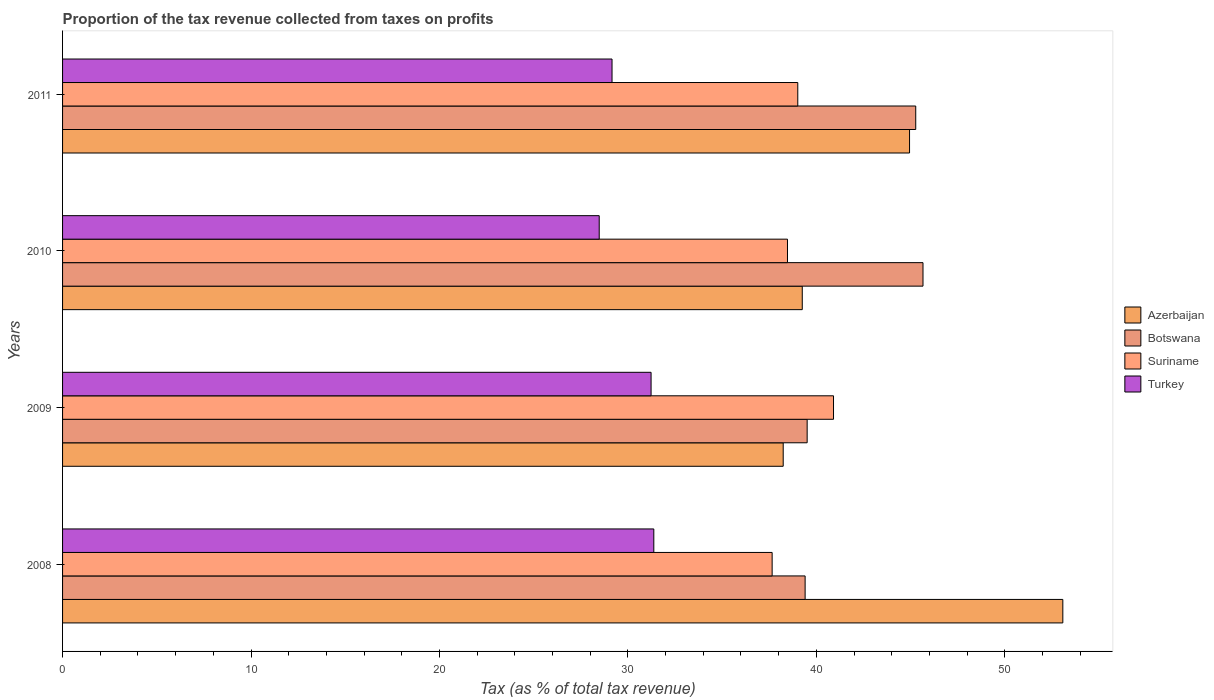How many groups of bars are there?
Keep it short and to the point. 4. Are the number of bars on each tick of the Y-axis equal?
Make the answer very short. Yes. What is the label of the 3rd group of bars from the top?
Give a very brief answer. 2009. In how many cases, is the number of bars for a given year not equal to the number of legend labels?
Provide a short and direct response. 0. What is the proportion of the tax revenue collected in Azerbaijan in 2009?
Ensure brevity in your answer.  38.24. Across all years, what is the maximum proportion of the tax revenue collected in Suriname?
Your response must be concise. 40.91. Across all years, what is the minimum proportion of the tax revenue collected in Azerbaijan?
Your answer should be compact. 38.24. In which year was the proportion of the tax revenue collected in Turkey minimum?
Your response must be concise. 2010. What is the total proportion of the tax revenue collected in Botswana in the graph?
Ensure brevity in your answer.  169.85. What is the difference between the proportion of the tax revenue collected in Botswana in 2008 and that in 2011?
Your response must be concise. -5.87. What is the difference between the proportion of the tax revenue collected in Turkey in 2010 and the proportion of the tax revenue collected in Azerbaijan in 2009?
Make the answer very short. -9.76. What is the average proportion of the tax revenue collected in Azerbaijan per year?
Your answer should be compact. 43.88. In the year 2009, what is the difference between the proportion of the tax revenue collected in Turkey and proportion of the tax revenue collected in Azerbaijan?
Your answer should be compact. -7.01. What is the ratio of the proportion of the tax revenue collected in Turkey in 2008 to that in 2009?
Give a very brief answer. 1. Is the difference between the proportion of the tax revenue collected in Turkey in 2009 and 2011 greater than the difference between the proportion of the tax revenue collected in Azerbaijan in 2009 and 2011?
Your answer should be very brief. Yes. What is the difference between the highest and the second highest proportion of the tax revenue collected in Azerbaijan?
Offer a very short reply. 8.13. What is the difference between the highest and the lowest proportion of the tax revenue collected in Suriname?
Give a very brief answer. 3.26. Is the sum of the proportion of the tax revenue collected in Turkey in 2010 and 2011 greater than the maximum proportion of the tax revenue collected in Botswana across all years?
Give a very brief answer. Yes. What does the 1st bar from the top in 2009 represents?
Your answer should be very brief. Turkey. What does the 3rd bar from the bottom in 2011 represents?
Provide a succinct answer. Suriname. How many bars are there?
Your answer should be very brief. 16. Are the values on the major ticks of X-axis written in scientific E-notation?
Your answer should be very brief. No. Does the graph contain grids?
Offer a very short reply. No. What is the title of the graph?
Provide a succinct answer. Proportion of the tax revenue collected from taxes on profits. Does "Curacao" appear as one of the legend labels in the graph?
Your answer should be compact. No. What is the label or title of the X-axis?
Your answer should be very brief. Tax (as % of total tax revenue). What is the label or title of the Y-axis?
Offer a very short reply. Years. What is the Tax (as % of total tax revenue) of Azerbaijan in 2008?
Offer a terse response. 53.08. What is the Tax (as % of total tax revenue) of Botswana in 2008?
Offer a terse response. 39.4. What is the Tax (as % of total tax revenue) of Suriname in 2008?
Offer a terse response. 37.65. What is the Tax (as % of total tax revenue) in Turkey in 2008?
Make the answer very short. 31.37. What is the Tax (as % of total tax revenue) of Azerbaijan in 2009?
Your answer should be very brief. 38.24. What is the Tax (as % of total tax revenue) in Botswana in 2009?
Keep it short and to the point. 39.51. What is the Tax (as % of total tax revenue) in Suriname in 2009?
Your answer should be compact. 40.91. What is the Tax (as % of total tax revenue) of Turkey in 2009?
Provide a short and direct response. 31.23. What is the Tax (as % of total tax revenue) of Azerbaijan in 2010?
Offer a very short reply. 39.25. What is the Tax (as % of total tax revenue) in Botswana in 2010?
Keep it short and to the point. 45.66. What is the Tax (as % of total tax revenue) of Suriname in 2010?
Provide a short and direct response. 38.47. What is the Tax (as % of total tax revenue) of Turkey in 2010?
Ensure brevity in your answer.  28.48. What is the Tax (as % of total tax revenue) of Azerbaijan in 2011?
Provide a succinct answer. 44.94. What is the Tax (as % of total tax revenue) of Botswana in 2011?
Provide a succinct answer. 45.27. What is the Tax (as % of total tax revenue) of Suriname in 2011?
Provide a succinct answer. 39.01. What is the Tax (as % of total tax revenue) in Turkey in 2011?
Ensure brevity in your answer.  29.16. Across all years, what is the maximum Tax (as % of total tax revenue) of Azerbaijan?
Offer a very short reply. 53.08. Across all years, what is the maximum Tax (as % of total tax revenue) in Botswana?
Give a very brief answer. 45.66. Across all years, what is the maximum Tax (as % of total tax revenue) in Suriname?
Give a very brief answer. 40.91. Across all years, what is the maximum Tax (as % of total tax revenue) of Turkey?
Keep it short and to the point. 31.37. Across all years, what is the minimum Tax (as % of total tax revenue) in Azerbaijan?
Ensure brevity in your answer.  38.24. Across all years, what is the minimum Tax (as % of total tax revenue) in Botswana?
Provide a short and direct response. 39.4. Across all years, what is the minimum Tax (as % of total tax revenue) of Suriname?
Your response must be concise. 37.65. Across all years, what is the minimum Tax (as % of total tax revenue) in Turkey?
Ensure brevity in your answer.  28.48. What is the total Tax (as % of total tax revenue) of Azerbaijan in the graph?
Give a very brief answer. 175.52. What is the total Tax (as % of total tax revenue) of Botswana in the graph?
Keep it short and to the point. 169.85. What is the total Tax (as % of total tax revenue) of Suriname in the graph?
Make the answer very short. 156.05. What is the total Tax (as % of total tax revenue) of Turkey in the graph?
Give a very brief answer. 120.24. What is the difference between the Tax (as % of total tax revenue) in Azerbaijan in 2008 and that in 2009?
Your response must be concise. 14.84. What is the difference between the Tax (as % of total tax revenue) of Botswana in 2008 and that in 2009?
Your response must be concise. -0.11. What is the difference between the Tax (as % of total tax revenue) of Suriname in 2008 and that in 2009?
Provide a short and direct response. -3.26. What is the difference between the Tax (as % of total tax revenue) of Turkey in 2008 and that in 2009?
Your answer should be very brief. 0.14. What is the difference between the Tax (as % of total tax revenue) in Azerbaijan in 2008 and that in 2010?
Your response must be concise. 13.83. What is the difference between the Tax (as % of total tax revenue) in Botswana in 2008 and that in 2010?
Provide a short and direct response. -6.26. What is the difference between the Tax (as % of total tax revenue) in Suriname in 2008 and that in 2010?
Offer a very short reply. -0.81. What is the difference between the Tax (as % of total tax revenue) in Turkey in 2008 and that in 2010?
Give a very brief answer. 2.9. What is the difference between the Tax (as % of total tax revenue) in Azerbaijan in 2008 and that in 2011?
Your response must be concise. 8.13. What is the difference between the Tax (as % of total tax revenue) of Botswana in 2008 and that in 2011?
Make the answer very short. -5.87. What is the difference between the Tax (as % of total tax revenue) of Suriname in 2008 and that in 2011?
Your answer should be compact. -1.36. What is the difference between the Tax (as % of total tax revenue) of Turkey in 2008 and that in 2011?
Your answer should be compact. 2.22. What is the difference between the Tax (as % of total tax revenue) of Azerbaijan in 2009 and that in 2010?
Offer a very short reply. -1.01. What is the difference between the Tax (as % of total tax revenue) in Botswana in 2009 and that in 2010?
Provide a short and direct response. -6.15. What is the difference between the Tax (as % of total tax revenue) in Suriname in 2009 and that in 2010?
Offer a terse response. 2.44. What is the difference between the Tax (as % of total tax revenue) of Turkey in 2009 and that in 2010?
Offer a terse response. 2.75. What is the difference between the Tax (as % of total tax revenue) of Azerbaijan in 2009 and that in 2011?
Make the answer very short. -6.7. What is the difference between the Tax (as % of total tax revenue) of Botswana in 2009 and that in 2011?
Provide a succinct answer. -5.76. What is the difference between the Tax (as % of total tax revenue) in Suriname in 2009 and that in 2011?
Give a very brief answer. 1.9. What is the difference between the Tax (as % of total tax revenue) in Turkey in 2009 and that in 2011?
Your answer should be very brief. 2.07. What is the difference between the Tax (as % of total tax revenue) of Azerbaijan in 2010 and that in 2011?
Keep it short and to the point. -5.69. What is the difference between the Tax (as % of total tax revenue) of Botswana in 2010 and that in 2011?
Keep it short and to the point. 0.39. What is the difference between the Tax (as % of total tax revenue) of Suriname in 2010 and that in 2011?
Your answer should be compact. -0.55. What is the difference between the Tax (as % of total tax revenue) of Turkey in 2010 and that in 2011?
Your answer should be compact. -0.68. What is the difference between the Tax (as % of total tax revenue) of Azerbaijan in 2008 and the Tax (as % of total tax revenue) of Botswana in 2009?
Your answer should be very brief. 13.57. What is the difference between the Tax (as % of total tax revenue) of Azerbaijan in 2008 and the Tax (as % of total tax revenue) of Suriname in 2009?
Give a very brief answer. 12.17. What is the difference between the Tax (as % of total tax revenue) of Azerbaijan in 2008 and the Tax (as % of total tax revenue) of Turkey in 2009?
Provide a short and direct response. 21.85. What is the difference between the Tax (as % of total tax revenue) in Botswana in 2008 and the Tax (as % of total tax revenue) in Suriname in 2009?
Give a very brief answer. -1.51. What is the difference between the Tax (as % of total tax revenue) in Botswana in 2008 and the Tax (as % of total tax revenue) in Turkey in 2009?
Your response must be concise. 8.17. What is the difference between the Tax (as % of total tax revenue) in Suriname in 2008 and the Tax (as % of total tax revenue) in Turkey in 2009?
Keep it short and to the point. 6.42. What is the difference between the Tax (as % of total tax revenue) of Azerbaijan in 2008 and the Tax (as % of total tax revenue) of Botswana in 2010?
Your answer should be very brief. 7.42. What is the difference between the Tax (as % of total tax revenue) of Azerbaijan in 2008 and the Tax (as % of total tax revenue) of Suriname in 2010?
Provide a short and direct response. 14.61. What is the difference between the Tax (as % of total tax revenue) of Azerbaijan in 2008 and the Tax (as % of total tax revenue) of Turkey in 2010?
Provide a short and direct response. 24.6. What is the difference between the Tax (as % of total tax revenue) in Botswana in 2008 and the Tax (as % of total tax revenue) in Suriname in 2010?
Make the answer very short. 0.94. What is the difference between the Tax (as % of total tax revenue) of Botswana in 2008 and the Tax (as % of total tax revenue) of Turkey in 2010?
Provide a succinct answer. 10.93. What is the difference between the Tax (as % of total tax revenue) of Suriname in 2008 and the Tax (as % of total tax revenue) of Turkey in 2010?
Ensure brevity in your answer.  9.18. What is the difference between the Tax (as % of total tax revenue) of Azerbaijan in 2008 and the Tax (as % of total tax revenue) of Botswana in 2011?
Offer a very short reply. 7.8. What is the difference between the Tax (as % of total tax revenue) in Azerbaijan in 2008 and the Tax (as % of total tax revenue) in Suriname in 2011?
Provide a short and direct response. 14.06. What is the difference between the Tax (as % of total tax revenue) of Azerbaijan in 2008 and the Tax (as % of total tax revenue) of Turkey in 2011?
Provide a short and direct response. 23.92. What is the difference between the Tax (as % of total tax revenue) in Botswana in 2008 and the Tax (as % of total tax revenue) in Suriname in 2011?
Keep it short and to the point. 0.39. What is the difference between the Tax (as % of total tax revenue) in Botswana in 2008 and the Tax (as % of total tax revenue) in Turkey in 2011?
Keep it short and to the point. 10.25. What is the difference between the Tax (as % of total tax revenue) in Suriname in 2008 and the Tax (as % of total tax revenue) in Turkey in 2011?
Your answer should be compact. 8.5. What is the difference between the Tax (as % of total tax revenue) of Azerbaijan in 2009 and the Tax (as % of total tax revenue) of Botswana in 2010?
Offer a terse response. -7.42. What is the difference between the Tax (as % of total tax revenue) of Azerbaijan in 2009 and the Tax (as % of total tax revenue) of Suriname in 2010?
Your answer should be compact. -0.23. What is the difference between the Tax (as % of total tax revenue) in Azerbaijan in 2009 and the Tax (as % of total tax revenue) in Turkey in 2010?
Your response must be concise. 9.76. What is the difference between the Tax (as % of total tax revenue) in Botswana in 2009 and the Tax (as % of total tax revenue) in Suriname in 2010?
Keep it short and to the point. 1.04. What is the difference between the Tax (as % of total tax revenue) in Botswana in 2009 and the Tax (as % of total tax revenue) in Turkey in 2010?
Give a very brief answer. 11.03. What is the difference between the Tax (as % of total tax revenue) in Suriname in 2009 and the Tax (as % of total tax revenue) in Turkey in 2010?
Ensure brevity in your answer.  12.43. What is the difference between the Tax (as % of total tax revenue) of Azerbaijan in 2009 and the Tax (as % of total tax revenue) of Botswana in 2011?
Keep it short and to the point. -7.03. What is the difference between the Tax (as % of total tax revenue) in Azerbaijan in 2009 and the Tax (as % of total tax revenue) in Suriname in 2011?
Your response must be concise. -0.77. What is the difference between the Tax (as % of total tax revenue) of Azerbaijan in 2009 and the Tax (as % of total tax revenue) of Turkey in 2011?
Ensure brevity in your answer.  9.08. What is the difference between the Tax (as % of total tax revenue) of Botswana in 2009 and the Tax (as % of total tax revenue) of Suriname in 2011?
Give a very brief answer. 0.5. What is the difference between the Tax (as % of total tax revenue) of Botswana in 2009 and the Tax (as % of total tax revenue) of Turkey in 2011?
Give a very brief answer. 10.35. What is the difference between the Tax (as % of total tax revenue) in Suriname in 2009 and the Tax (as % of total tax revenue) in Turkey in 2011?
Offer a very short reply. 11.75. What is the difference between the Tax (as % of total tax revenue) of Azerbaijan in 2010 and the Tax (as % of total tax revenue) of Botswana in 2011?
Keep it short and to the point. -6.02. What is the difference between the Tax (as % of total tax revenue) of Azerbaijan in 2010 and the Tax (as % of total tax revenue) of Suriname in 2011?
Keep it short and to the point. 0.24. What is the difference between the Tax (as % of total tax revenue) of Azerbaijan in 2010 and the Tax (as % of total tax revenue) of Turkey in 2011?
Give a very brief answer. 10.09. What is the difference between the Tax (as % of total tax revenue) of Botswana in 2010 and the Tax (as % of total tax revenue) of Suriname in 2011?
Your response must be concise. 6.64. What is the difference between the Tax (as % of total tax revenue) of Botswana in 2010 and the Tax (as % of total tax revenue) of Turkey in 2011?
Provide a short and direct response. 16.5. What is the difference between the Tax (as % of total tax revenue) in Suriname in 2010 and the Tax (as % of total tax revenue) in Turkey in 2011?
Your answer should be compact. 9.31. What is the average Tax (as % of total tax revenue) of Azerbaijan per year?
Ensure brevity in your answer.  43.88. What is the average Tax (as % of total tax revenue) in Botswana per year?
Ensure brevity in your answer.  42.46. What is the average Tax (as % of total tax revenue) in Suriname per year?
Your answer should be compact. 39.01. What is the average Tax (as % of total tax revenue) of Turkey per year?
Offer a terse response. 30.06. In the year 2008, what is the difference between the Tax (as % of total tax revenue) of Azerbaijan and Tax (as % of total tax revenue) of Botswana?
Your answer should be compact. 13.67. In the year 2008, what is the difference between the Tax (as % of total tax revenue) in Azerbaijan and Tax (as % of total tax revenue) in Suriname?
Keep it short and to the point. 15.43. In the year 2008, what is the difference between the Tax (as % of total tax revenue) in Azerbaijan and Tax (as % of total tax revenue) in Turkey?
Offer a very short reply. 21.7. In the year 2008, what is the difference between the Tax (as % of total tax revenue) in Botswana and Tax (as % of total tax revenue) in Suriname?
Your answer should be very brief. 1.75. In the year 2008, what is the difference between the Tax (as % of total tax revenue) of Botswana and Tax (as % of total tax revenue) of Turkey?
Keep it short and to the point. 8.03. In the year 2008, what is the difference between the Tax (as % of total tax revenue) in Suriname and Tax (as % of total tax revenue) in Turkey?
Keep it short and to the point. 6.28. In the year 2009, what is the difference between the Tax (as % of total tax revenue) in Azerbaijan and Tax (as % of total tax revenue) in Botswana?
Ensure brevity in your answer.  -1.27. In the year 2009, what is the difference between the Tax (as % of total tax revenue) in Azerbaijan and Tax (as % of total tax revenue) in Suriname?
Provide a succinct answer. -2.67. In the year 2009, what is the difference between the Tax (as % of total tax revenue) of Azerbaijan and Tax (as % of total tax revenue) of Turkey?
Offer a terse response. 7.01. In the year 2009, what is the difference between the Tax (as % of total tax revenue) of Botswana and Tax (as % of total tax revenue) of Suriname?
Offer a terse response. -1.4. In the year 2009, what is the difference between the Tax (as % of total tax revenue) in Botswana and Tax (as % of total tax revenue) in Turkey?
Make the answer very short. 8.28. In the year 2009, what is the difference between the Tax (as % of total tax revenue) of Suriname and Tax (as % of total tax revenue) of Turkey?
Give a very brief answer. 9.68. In the year 2010, what is the difference between the Tax (as % of total tax revenue) of Azerbaijan and Tax (as % of total tax revenue) of Botswana?
Ensure brevity in your answer.  -6.41. In the year 2010, what is the difference between the Tax (as % of total tax revenue) in Azerbaijan and Tax (as % of total tax revenue) in Suriname?
Provide a succinct answer. 0.78. In the year 2010, what is the difference between the Tax (as % of total tax revenue) of Azerbaijan and Tax (as % of total tax revenue) of Turkey?
Your response must be concise. 10.77. In the year 2010, what is the difference between the Tax (as % of total tax revenue) of Botswana and Tax (as % of total tax revenue) of Suriname?
Ensure brevity in your answer.  7.19. In the year 2010, what is the difference between the Tax (as % of total tax revenue) in Botswana and Tax (as % of total tax revenue) in Turkey?
Your response must be concise. 17.18. In the year 2010, what is the difference between the Tax (as % of total tax revenue) in Suriname and Tax (as % of total tax revenue) in Turkey?
Your answer should be compact. 9.99. In the year 2011, what is the difference between the Tax (as % of total tax revenue) in Azerbaijan and Tax (as % of total tax revenue) in Botswana?
Provide a succinct answer. -0.33. In the year 2011, what is the difference between the Tax (as % of total tax revenue) of Azerbaijan and Tax (as % of total tax revenue) of Suriname?
Keep it short and to the point. 5.93. In the year 2011, what is the difference between the Tax (as % of total tax revenue) of Azerbaijan and Tax (as % of total tax revenue) of Turkey?
Give a very brief answer. 15.79. In the year 2011, what is the difference between the Tax (as % of total tax revenue) in Botswana and Tax (as % of total tax revenue) in Suriname?
Give a very brief answer. 6.26. In the year 2011, what is the difference between the Tax (as % of total tax revenue) in Botswana and Tax (as % of total tax revenue) in Turkey?
Provide a succinct answer. 16.12. In the year 2011, what is the difference between the Tax (as % of total tax revenue) of Suriname and Tax (as % of total tax revenue) of Turkey?
Your response must be concise. 9.86. What is the ratio of the Tax (as % of total tax revenue) in Azerbaijan in 2008 to that in 2009?
Your answer should be compact. 1.39. What is the ratio of the Tax (as % of total tax revenue) in Suriname in 2008 to that in 2009?
Ensure brevity in your answer.  0.92. What is the ratio of the Tax (as % of total tax revenue) in Turkey in 2008 to that in 2009?
Give a very brief answer. 1. What is the ratio of the Tax (as % of total tax revenue) in Azerbaijan in 2008 to that in 2010?
Offer a terse response. 1.35. What is the ratio of the Tax (as % of total tax revenue) in Botswana in 2008 to that in 2010?
Your answer should be very brief. 0.86. What is the ratio of the Tax (as % of total tax revenue) of Suriname in 2008 to that in 2010?
Offer a very short reply. 0.98. What is the ratio of the Tax (as % of total tax revenue) of Turkey in 2008 to that in 2010?
Your answer should be very brief. 1.1. What is the ratio of the Tax (as % of total tax revenue) of Azerbaijan in 2008 to that in 2011?
Your response must be concise. 1.18. What is the ratio of the Tax (as % of total tax revenue) in Botswana in 2008 to that in 2011?
Give a very brief answer. 0.87. What is the ratio of the Tax (as % of total tax revenue) in Suriname in 2008 to that in 2011?
Give a very brief answer. 0.97. What is the ratio of the Tax (as % of total tax revenue) of Turkey in 2008 to that in 2011?
Provide a short and direct response. 1.08. What is the ratio of the Tax (as % of total tax revenue) of Azerbaijan in 2009 to that in 2010?
Keep it short and to the point. 0.97. What is the ratio of the Tax (as % of total tax revenue) of Botswana in 2009 to that in 2010?
Provide a short and direct response. 0.87. What is the ratio of the Tax (as % of total tax revenue) of Suriname in 2009 to that in 2010?
Your answer should be very brief. 1.06. What is the ratio of the Tax (as % of total tax revenue) in Turkey in 2009 to that in 2010?
Give a very brief answer. 1.1. What is the ratio of the Tax (as % of total tax revenue) of Azerbaijan in 2009 to that in 2011?
Your response must be concise. 0.85. What is the ratio of the Tax (as % of total tax revenue) of Botswana in 2009 to that in 2011?
Offer a very short reply. 0.87. What is the ratio of the Tax (as % of total tax revenue) in Suriname in 2009 to that in 2011?
Give a very brief answer. 1.05. What is the ratio of the Tax (as % of total tax revenue) in Turkey in 2009 to that in 2011?
Ensure brevity in your answer.  1.07. What is the ratio of the Tax (as % of total tax revenue) of Azerbaijan in 2010 to that in 2011?
Keep it short and to the point. 0.87. What is the ratio of the Tax (as % of total tax revenue) of Botswana in 2010 to that in 2011?
Offer a very short reply. 1.01. What is the ratio of the Tax (as % of total tax revenue) in Suriname in 2010 to that in 2011?
Provide a short and direct response. 0.99. What is the ratio of the Tax (as % of total tax revenue) in Turkey in 2010 to that in 2011?
Your answer should be very brief. 0.98. What is the difference between the highest and the second highest Tax (as % of total tax revenue) of Azerbaijan?
Offer a terse response. 8.13. What is the difference between the highest and the second highest Tax (as % of total tax revenue) in Botswana?
Provide a short and direct response. 0.39. What is the difference between the highest and the second highest Tax (as % of total tax revenue) of Suriname?
Give a very brief answer. 1.9. What is the difference between the highest and the second highest Tax (as % of total tax revenue) of Turkey?
Your response must be concise. 0.14. What is the difference between the highest and the lowest Tax (as % of total tax revenue) of Azerbaijan?
Offer a very short reply. 14.84. What is the difference between the highest and the lowest Tax (as % of total tax revenue) in Botswana?
Your response must be concise. 6.26. What is the difference between the highest and the lowest Tax (as % of total tax revenue) of Suriname?
Your answer should be compact. 3.26. What is the difference between the highest and the lowest Tax (as % of total tax revenue) in Turkey?
Keep it short and to the point. 2.9. 